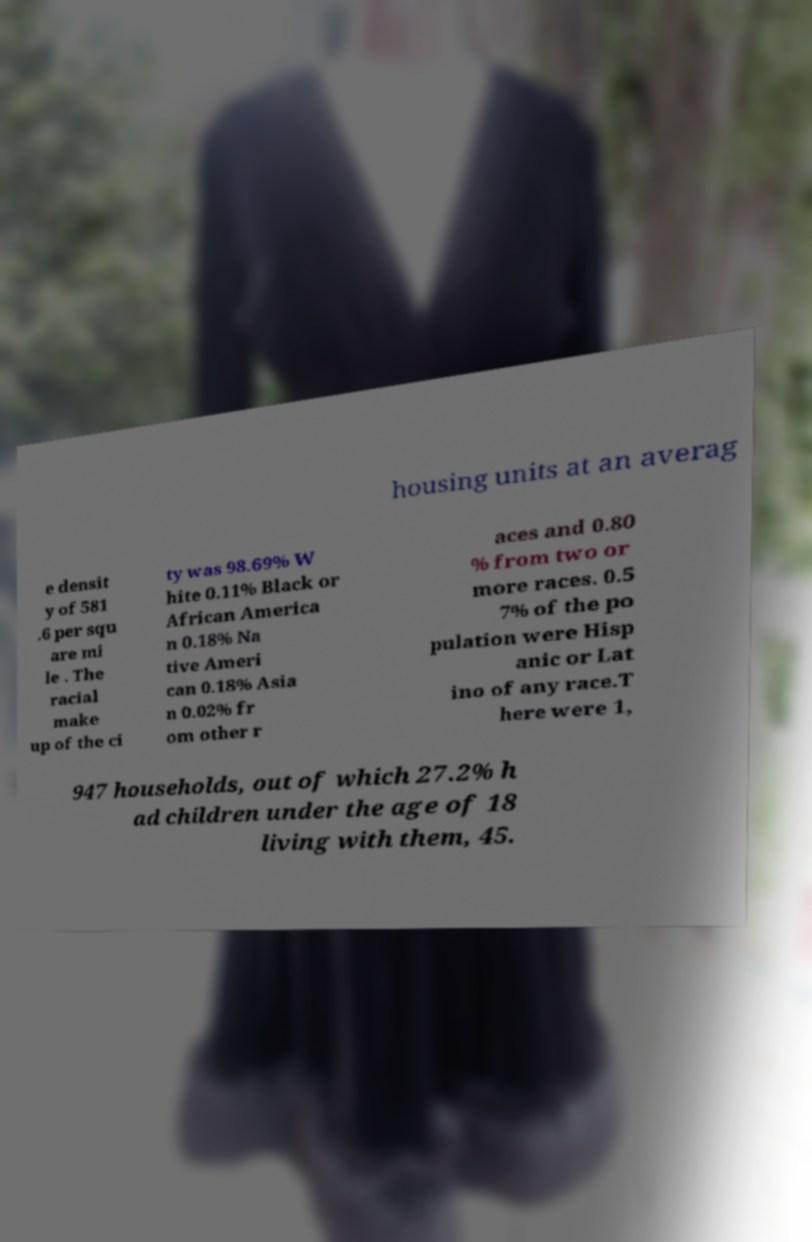Could you assist in decoding the text presented in this image and type it out clearly? housing units at an averag e densit y of 581 .6 per squ are mi le . The racial make up of the ci ty was 98.69% W hite 0.11% Black or African America n 0.18% Na tive Ameri can 0.18% Asia n 0.02% fr om other r aces and 0.80 % from two or more races. 0.5 7% of the po pulation were Hisp anic or Lat ino of any race.T here were 1, 947 households, out of which 27.2% h ad children under the age of 18 living with them, 45. 